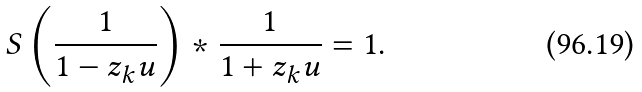<formula> <loc_0><loc_0><loc_500><loc_500>S \left ( \frac { 1 } { 1 - z _ { k } u } \right ) \ast \frac { 1 } { 1 + z _ { k } u } = 1 .</formula> 